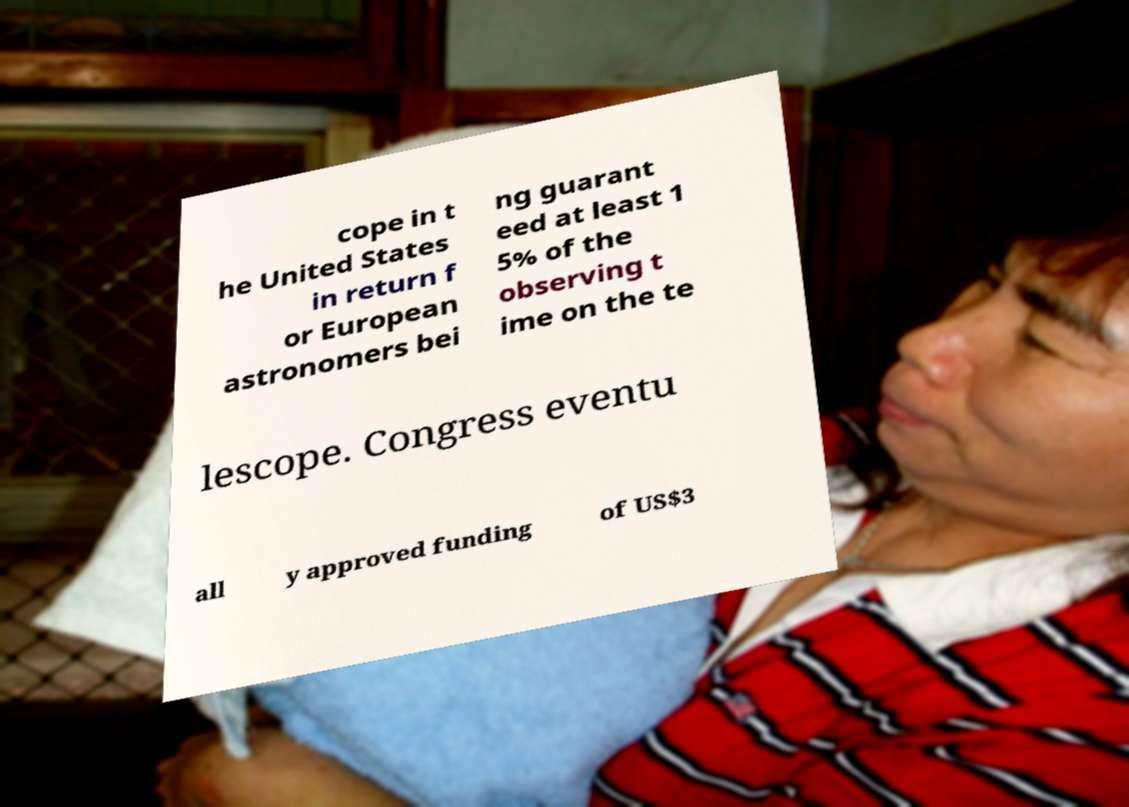Could you assist in decoding the text presented in this image and type it out clearly? cope in t he United States in return f or European astronomers bei ng guarant eed at least 1 5% of the observing t ime on the te lescope. Congress eventu all y approved funding of US$3 